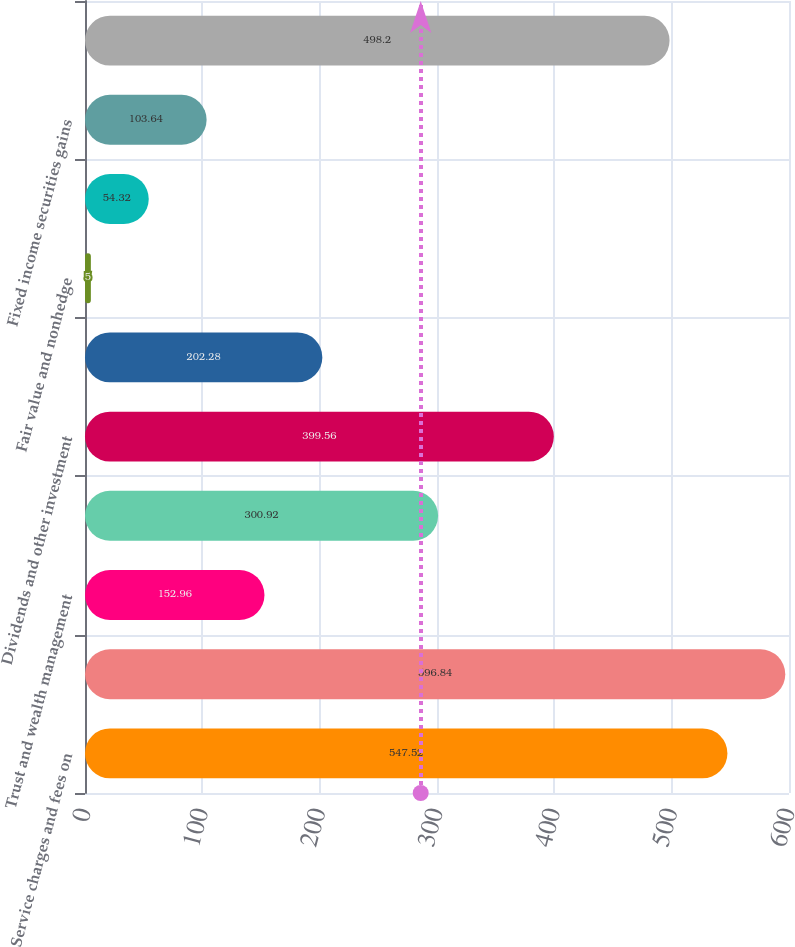<chart> <loc_0><loc_0><loc_500><loc_500><bar_chart><fcel>Service charges and fees on<fcel>Other service charges<fcel>Trust and wealth management<fcel>Capital markets and foreign<fcel>Dividends and other investment<fcel>Loan sales and servicing<fcel>Fair value and nonhedge<fcel>Equity securities gains net<fcel>Fixed income securities gains<fcel>Impairment losses on<nl><fcel>547.52<fcel>596.84<fcel>152.96<fcel>300.92<fcel>399.56<fcel>202.28<fcel>5<fcel>54.32<fcel>103.64<fcel>498.2<nl></chart> 